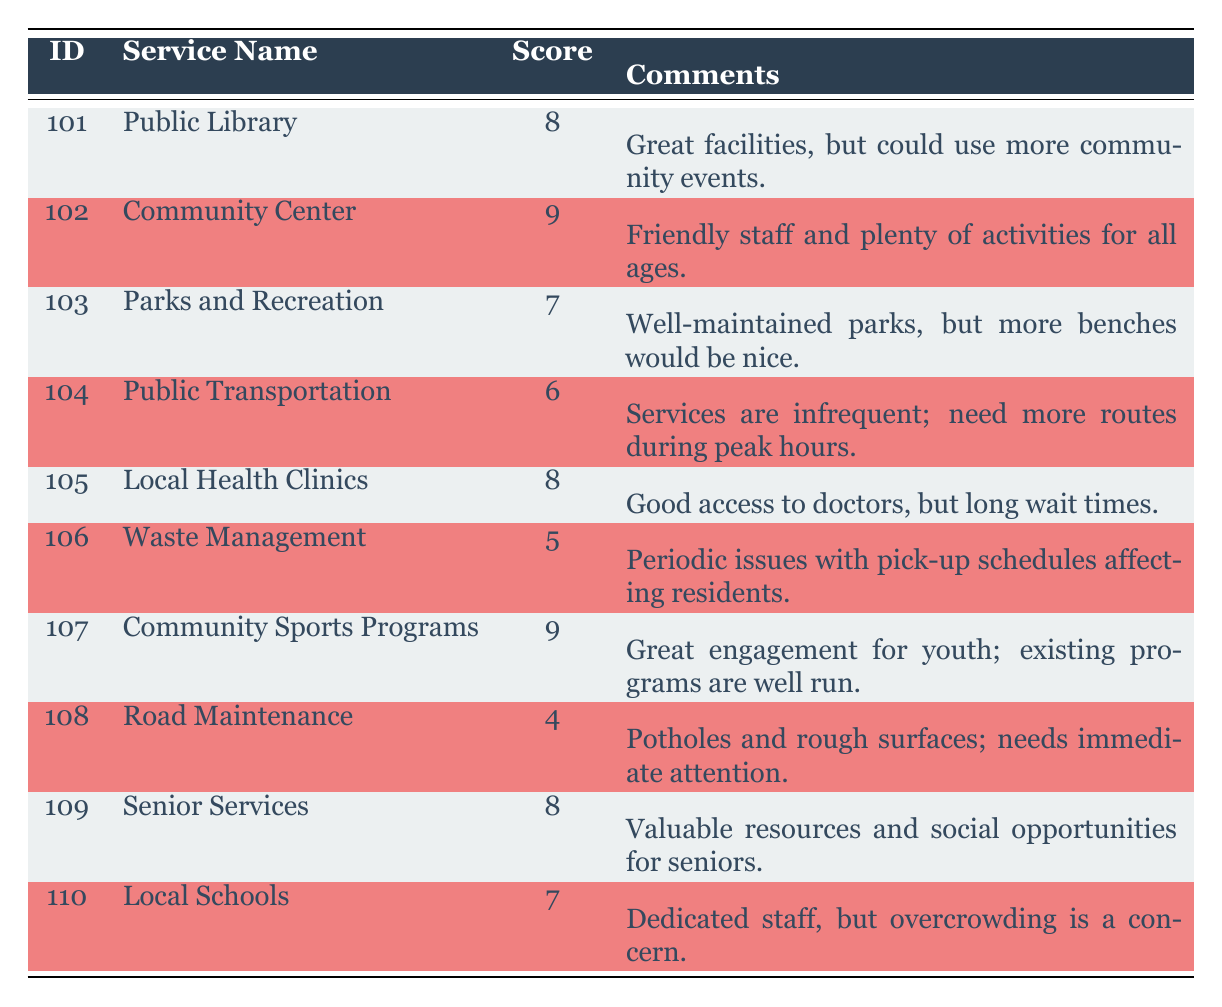What is the satisfaction score for the Community Center? The satisfaction score for the Community Center is listed directly in the table under the corresponding row, which shows a score of 9.
Answer: 9 Which service has the lowest satisfaction score, and what is the score? The service with the lowest satisfaction score is Road Maintenance, which has a score of 4, as indicated in the table.
Answer: Road Maintenance, 4 What is the average satisfaction score across all services listed? To determine the average, first sum the satisfaction scores: 8 + 9 + 7 + 6 + 8 + 5 + 9 + 4 + 8 + 7 = 81. There are 10 services, so the average is 81 divided by 10, which equals 8.1.
Answer: 8.1 Are there any services that received a satisfaction score of 6 or higher? Yes, by reviewing the table, the services with scores of 6 or higher are the Public Library, Community Center, Parks and Recreation, Local Health Clinics, Community Sports Programs, Senior Services, and Local Schools.
Answer: Yes How many services received a satisfaction score of 8? By scanning the table, there are three services with a score of 8: Public Library, Local Health Clinics, and Senior Services, confirmed by counting the instances in the score column.
Answer: 3 Which service has comments indicating a need for more community events? The Public Library has comments stating "Great facilities, but could use more community events," which can be located in the comments column.
Answer: Public Library Is it true that all services have a satisfaction score above 5? No, Waste Management, with a satisfaction score of 5, and Road Maintenance, with a score of 4, indicate that not all services exceed a score of 5.
Answer: No What is the difference between the highest and the lowest satisfaction scores in the table? The highest score is 9 (Community Center and Community Sports Programs) and the lowest score is 4 (Road Maintenance). The difference is 9 - 4 = 5.
Answer: 5 What percentage of services have a satisfaction score of 7 or higher? There are 6 services (Public Library, Community Center, Parks and Recreation, Local Health Clinics, Community Sports Programs, Senior Services, and Local Schools) with a score of 7 or higher, out of a total of 10 services. Therefore, the percentage is (6/10) * 100 = 60%.
Answer: 60% 